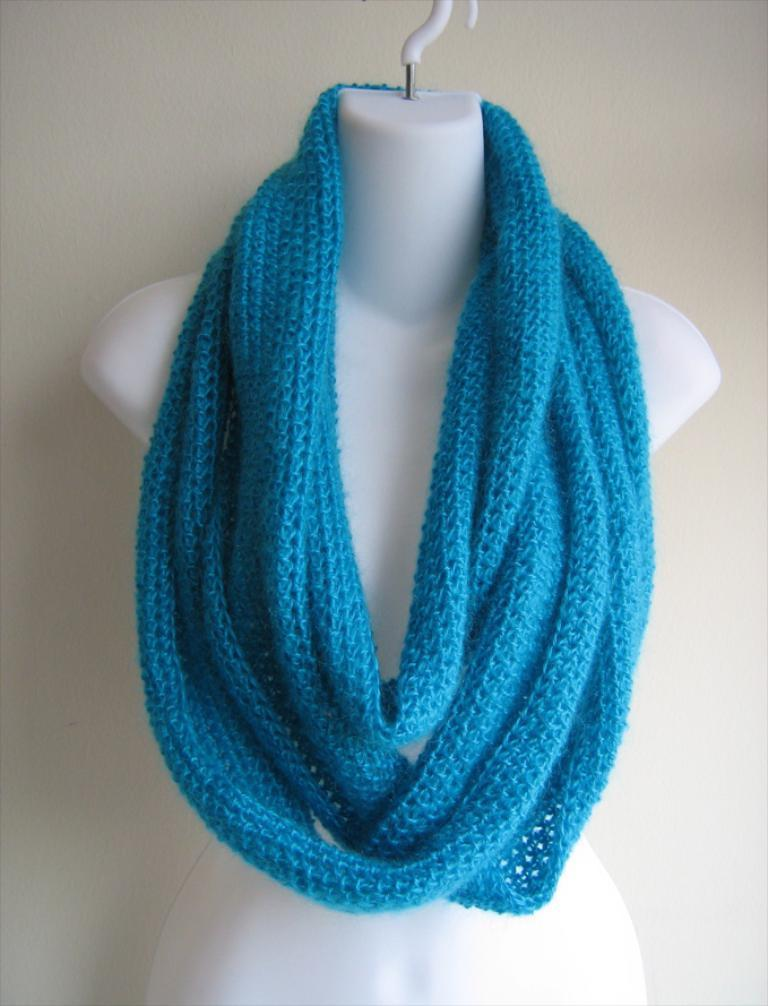What type of clothing accessory is in the image? There is a scarf in the image. Is the scarf being worn by anyone in the image? No, the scarf is on a mannequin. What type of vegetable is being used to solve arithmetic problems in the image? There is no vegetable, such as a yam, present in the image, nor are there any arithmetic problems being solved. 